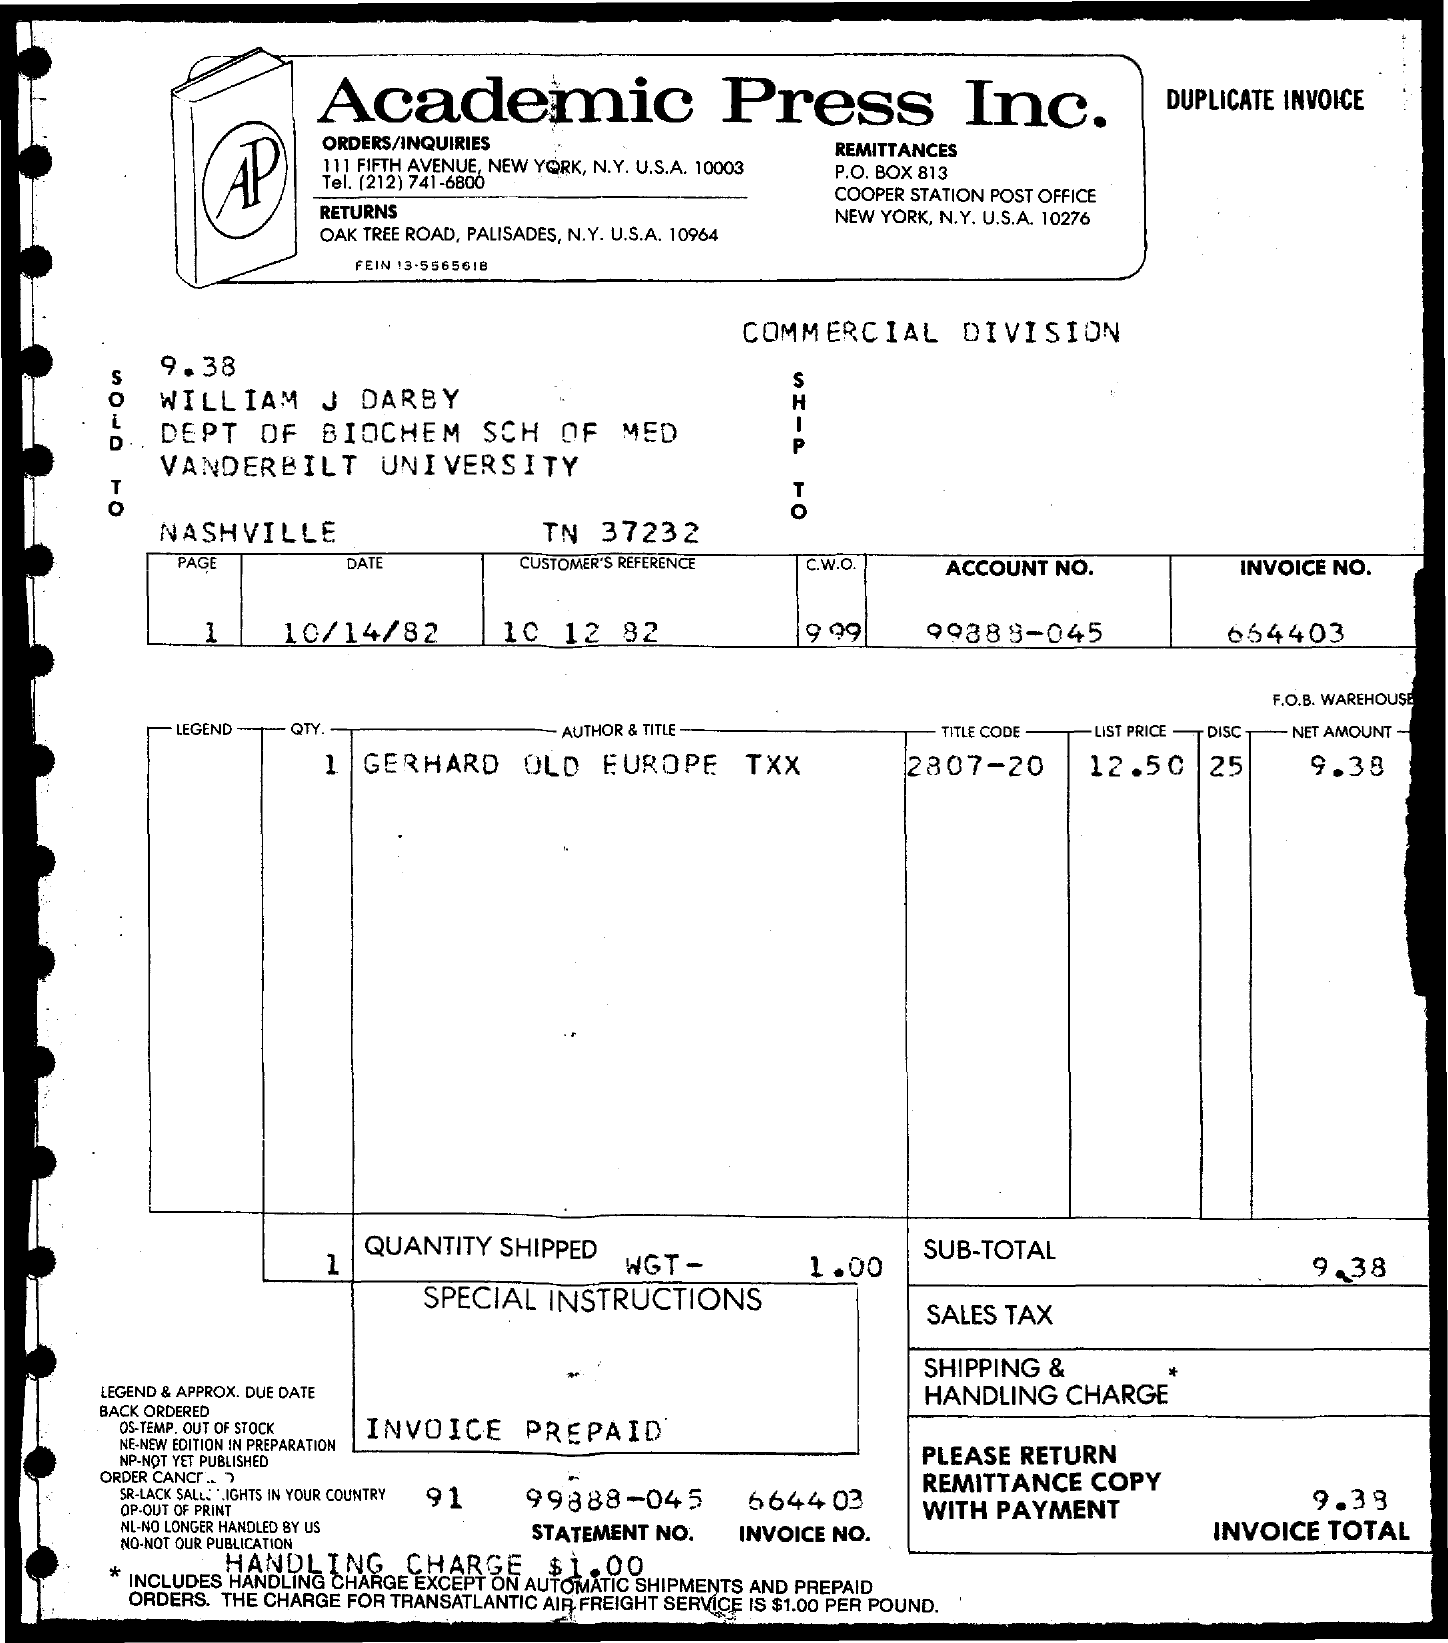Can you tell me what item was purchased, according to the invoice? The item purchased, as listed on the invoice, is titled 'GERHARD OLD EUROPE TXX.' 